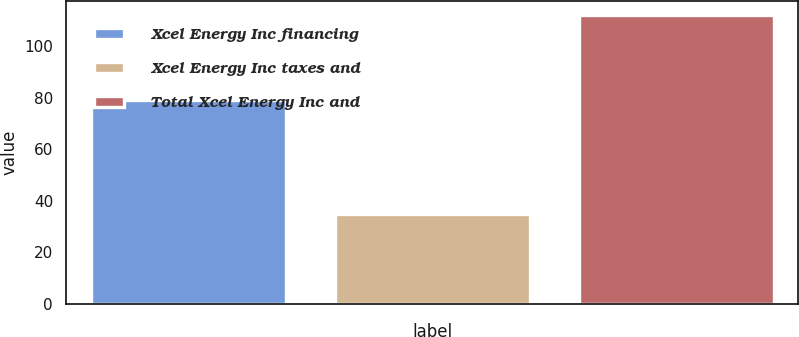<chart> <loc_0><loc_0><loc_500><loc_500><bar_chart><fcel>Xcel Energy Inc financing<fcel>Xcel Energy Inc taxes and<fcel>Total Xcel Energy Inc and<nl><fcel>79<fcel>35<fcel>112<nl></chart> 